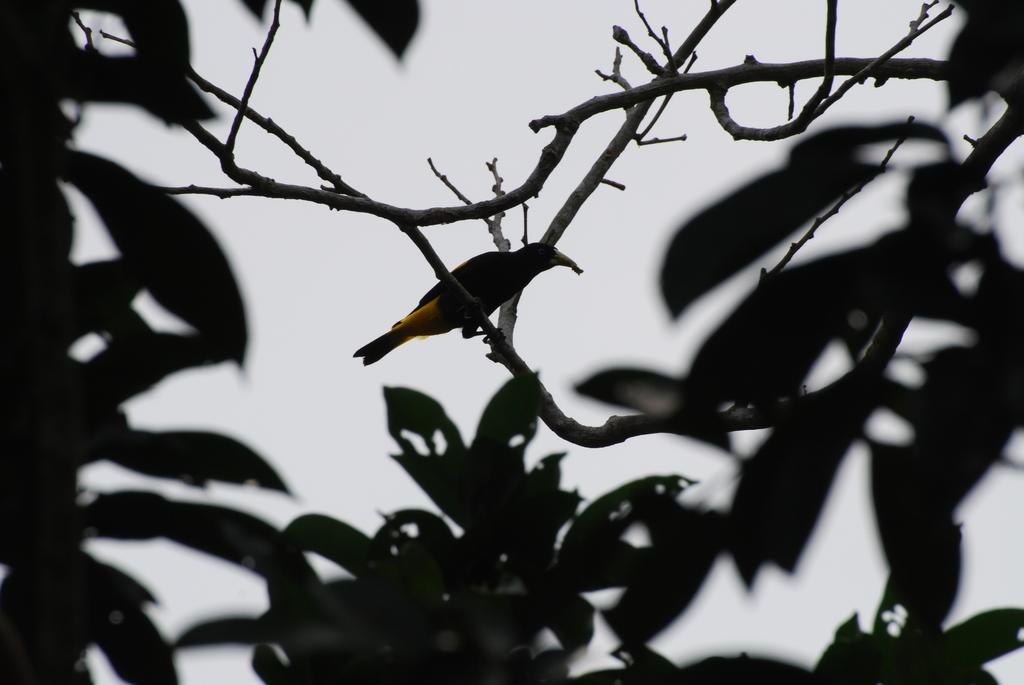What type of animal is in the image? There is a bird in the image. Where is the bird located? The bird is on a branch. What else can be seen in the image besides the bird? There are leaves in the image. What can be seen in the background of the image? The sky is visible in the background of the image. How many friends are the boys playing with in the image? There are no boys or friends present in the image; it features a bird on a branch with leaves and the sky visible in the background. 